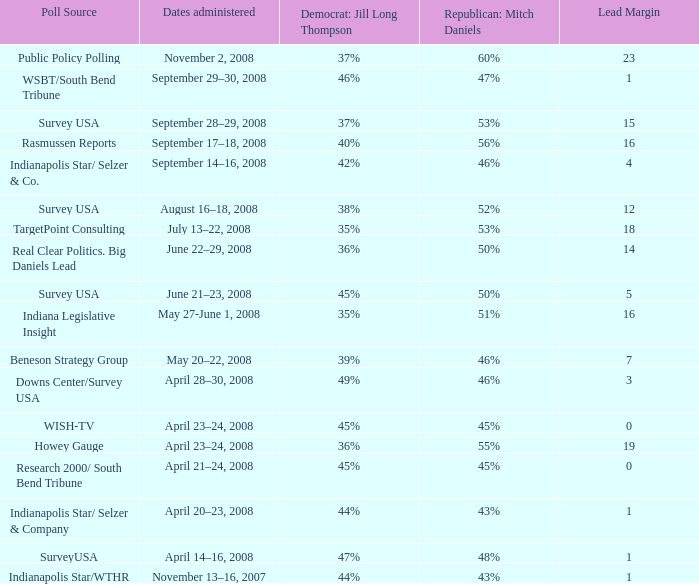What is the smallest lead margin when republican: mitch daniels had a 48% poll rating? 1.0. 